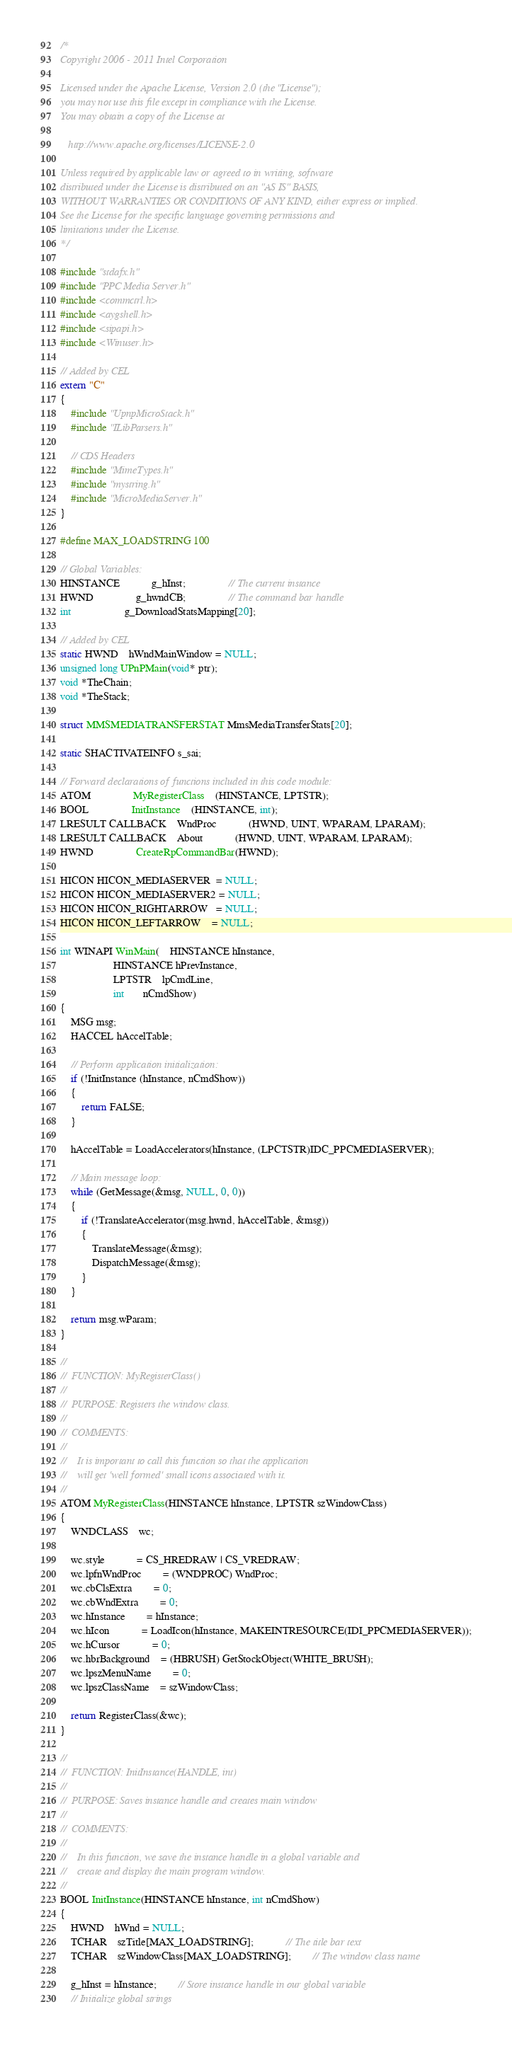Convert code to text. <code><loc_0><loc_0><loc_500><loc_500><_C++_>/*   
Copyright 2006 - 2011 Intel Corporation

Licensed under the Apache License, Version 2.0 (the "License");
you may not use this file except in compliance with the License.
You may obtain a copy of the License at

   http://www.apache.org/licenses/LICENSE-2.0

Unless required by applicable law or agreed to in writing, software
distributed under the License is distributed on an "AS IS" BASIS,
WITHOUT WARRANTIES OR CONDITIONS OF ANY KIND, either express or implied.
See the License for the specific language governing permissions and
limitations under the License.
*/

#include "stdafx.h"
#include "PPC Media Server.h"
#include <commctrl.h>
#include <aygshell.h>
#include <sipapi.h>
#include <Winuser.h>

// Added by CEL
extern "C"
{
	#include "UpnpMicroStack.h"
	#include "ILibParsers.h"

	// CDS Headers
	#include "MimeTypes.h"
	#include "mystring.h"
	#include "MicroMediaServer.h"
}

#define MAX_LOADSTRING 100

// Global Variables:
HINSTANCE			g_hInst;				// The current instance
HWND				g_hwndCB;				// The command bar handle
int					g_DownloadStatsMapping[20];

// Added by CEL
static HWND	hWndMainWindow = NULL;
unsigned long UPnPMain(void* ptr);
void *TheChain;
void *TheStack;

struct MMSMEDIATRANSFERSTAT MmsMediaTransferStats[20];

static SHACTIVATEINFO s_sai;

// Forward declarations of functions included in this code module:
ATOM				MyRegisterClass	(HINSTANCE, LPTSTR);
BOOL				InitInstance	(HINSTANCE, int);
LRESULT CALLBACK	WndProc			(HWND, UINT, WPARAM, LPARAM);
LRESULT CALLBACK	About			(HWND, UINT, WPARAM, LPARAM);
HWND				CreateRpCommandBar(HWND);

HICON HICON_MEDIASERVER  = NULL;
HICON HICON_MEDIASERVER2 = NULL;
HICON HICON_RIGHTARROW   = NULL;
HICON HICON_LEFTARROW    = NULL;

int WINAPI WinMain(	HINSTANCE hInstance,
					HINSTANCE hPrevInstance,
					LPTSTR    lpCmdLine,
					int       nCmdShow)
{
	MSG msg;
	HACCEL hAccelTable;

	// Perform application initialization:
	if (!InitInstance (hInstance, nCmdShow)) 
	{
		return FALSE;
	}

	hAccelTable = LoadAccelerators(hInstance, (LPCTSTR)IDC_PPCMEDIASERVER);

	// Main message loop:
	while (GetMessage(&msg, NULL, 0, 0)) 
	{
		if (!TranslateAccelerator(msg.hwnd, hAccelTable, &msg)) 
		{
			TranslateMessage(&msg);
			DispatchMessage(&msg);
		}
	}

	return msg.wParam;
}

//
//  FUNCTION: MyRegisterClass()
//
//  PURPOSE: Registers the window class.
//
//  COMMENTS:
//
//    It is important to call this function so that the application 
//    will get 'well formed' small icons associated with it.
//
ATOM MyRegisterClass(HINSTANCE hInstance, LPTSTR szWindowClass)
{
	WNDCLASS	wc;

    wc.style			= CS_HREDRAW | CS_VREDRAW;
    wc.lpfnWndProc		= (WNDPROC) WndProc;
    wc.cbClsExtra		= 0;
    wc.cbWndExtra		= 0;
    wc.hInstance		= hInstance;
    wc.hIcon			= LoadIcon(hInstance, MAKEINTRESOURCE(IDI_PPCMEDIASERVER));
    wc.hCursor			= 0;
    wc.hbrBackground	= (HBRUSH) GetStockObject(WHITE_BRUSH);
    wc.lpszMenuName		= 0;
    wc.lpszClassName	= szWindowClass;

	return RegisterClass(&wc);
}

//
//  FUNCTION: InitInstance(HANDLE, int)
//
//  PURPOSE: Saves instance handle and creates main window
//
//  COMMENTS:
//
//    In this function, we save the instance handle in a global variable and
//    create and display the main program window.
//
BOOL InitInstance(HINSTANCE hInstance, int nCmdShow)
{
	HWND	hWnd = NULL;
	TCHAR	szTitle[MAX_LOADSTRING];			// The title bar text
	TCHAR	szWindowClass[MAX_LOADSTRING];		// The window class name

	g_hInst = hInstance;		// Store instance handle in our global variable
	// Initialize global strings</code> 